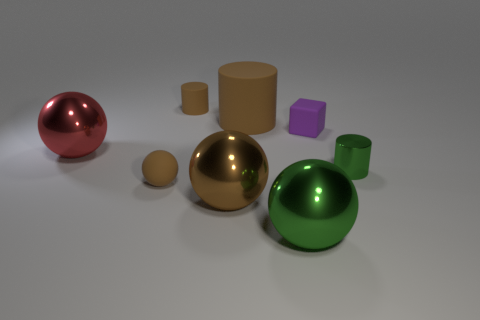What materials do the objects seem to be made of? The objects in the image appear to have smooth, reflective surfaces commonly associated with materials like polished metal or plastic. The mirror-like finish on the red hemisphere, the golden sphere, and the green sphere suggests a metallic quality, while the cylindrical objects and the cubes might be made of a matte plastic due to their less reflective nature. 